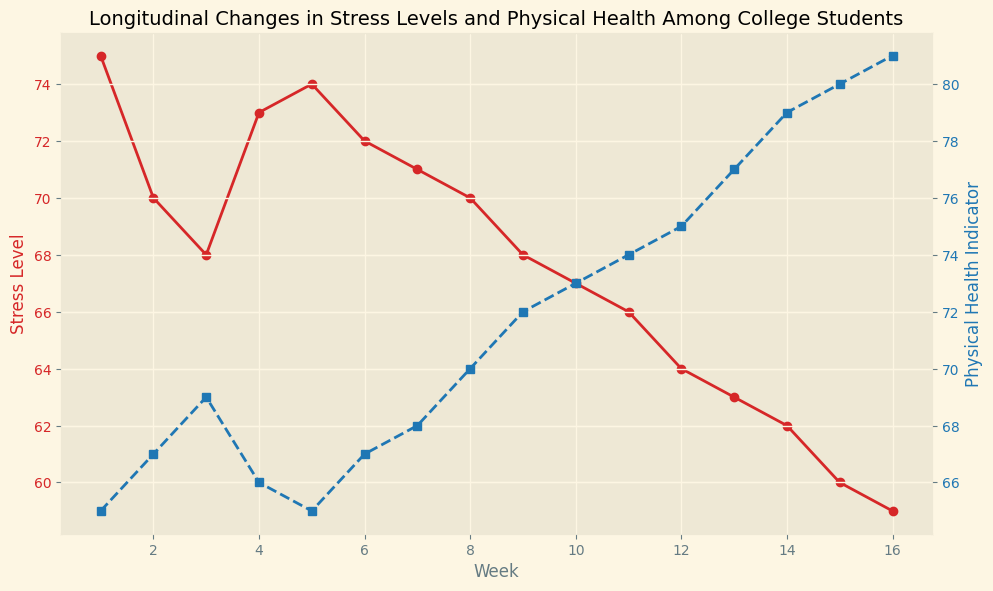What trend is observed in the stress levels over the course of the semester? Stress levels generally decrease as the semester progresses, starting at 75 in Week 1 and ending at 59 in Week 16.
Answer: Decreasing trend How does the physical health indicator change from Week 1 to Week 16? The physical health indicator increases over time, starting at 65 in Week 1 and reaching 81 by Week 16.
Answer: Increasing trend In which week do stress levels and physical health indicators intersect or are closest to each other? The closest point is around Week 9, where stress levels are 68 and physical health indicators are 72.
Answer: Week 9 Do stress levels and physical health indicators show opposite trends? Yes, stress levels generally decrease while physical health indicators increase over the semester.
Answer: Yes In which week does stress level have the largest decline compared to the previous week? The largest decline in stress levels occurs between Week 14 (62) and Week 15 (60).
Answer: Week 15 Which week shows the highest stress level and the lowest physical health indicator respectively? The highest stress level is observed in Week 1 (75) and the lowest physical health indicator is also in Week 1 (65).
Answer: Week 1 What is the difference in the physical health indicator between Week 1 and Week 16? The physical health indicator increases from 65 in Week 1 to 81 in Week 16, resulting in a difference of 16.
Answer: 16 What week shows equal or the closest distance between the stress level and physical health indicator lines? Week 8 shows the values as 70 and 70, making them equal at this point.
Answer: Week 8 How does the stress level in Week 10 compare to the physical health indicator in the same week? In Week 10, the stress level is 67, while the physical health indicator is 73, indicating that the physical health indicator is higher.
Answer: Physical health indicator is higher When did the stress level first drop below 70? The stress level first dropped below 70 in Week 9, where it reached 68.
Answer: Week 9 What is the difference in stress levels between the highest peak and the lowest point? The highest stress level is 75 and the lowest is 59, resulting in a difference of 16.
Answer: 16 